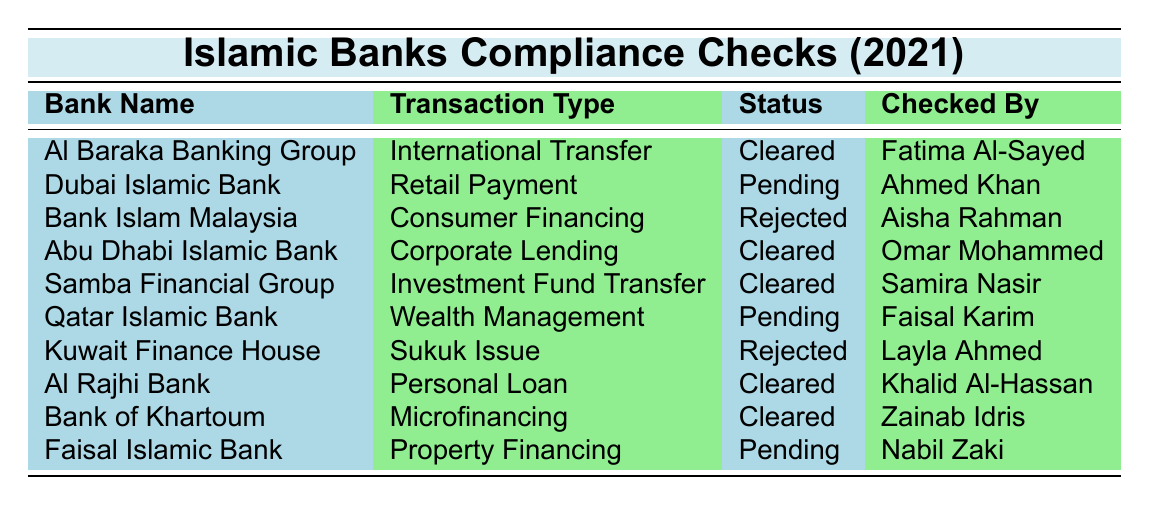What is the status of compliance checks for Bank Islam Malaysia? Referring to the table, Bank Islam Malaysia has a status of "Rejected" for the compliance check conducted on Consumer Financing on 2021-03-20.
Answer: Rejected How many compliance checks were conducted in total? The table lists 10 compliance checks across various banks, so the total number is 10.
Answer: 10 Which bank had a compliance check for an International Transfer transaction? The table shows that Al Baraka Banking Group conducted a compliance check for an International Transfer on 2021-04-15.
Answer: Al Baraka Banking Group Was any compliance check conducted by Dubai Islamic Bank approved in 2021? The status for Dubai Islamic Bank's compliance check on Retail Payment is "Pending," thus it was not approved.
Answer: No Which transaction type had the earliest compliance check date? Looking at the compliance check dates, the earliest date is 2021-01-10 for Al Rajhi Bank's Personal Loan.
Answer: Personal Loan How many compliance checks were cleared in total? The table lists 7 cleared checks out of the 10 total checks, namely: Al Baraka Banking Group, Abu Dhabi Islamic Bank, Samba Financial Group, Al Rajhi Bank, and Bank of Khartoum.
Answer: 7 What is the name of the compliance officer for Al Baraka Banking Group? The table indicates that the compliance officer for Al Baraka Banking Group is Fatima Al-Sayed.
Answer: Fatima Al-Sayed Which bank's compliance check was rejected for non-compliance with Shariah principles? According to the table, Kuwait Finance House's compliance check was rejected for non-compliance with Shariah principles.
Answer: Kuwait Finance House How many pending compliance checks are there, and what are their reasons? There are 3 pending compliance checks for Dubai Islamic Bank (suspicious activity alert), Qatar Islamic Bank (client's source of wealth verification), and Faisal Islamic Bank (land ownership verification).
Answer: 3 pending checks What is the total number of compliance checks conducted on Retail Payments? The table shows that there is only 1 compliance check conducted on Retail Payments by Dubai Islamic Bank.
Answer: 1 